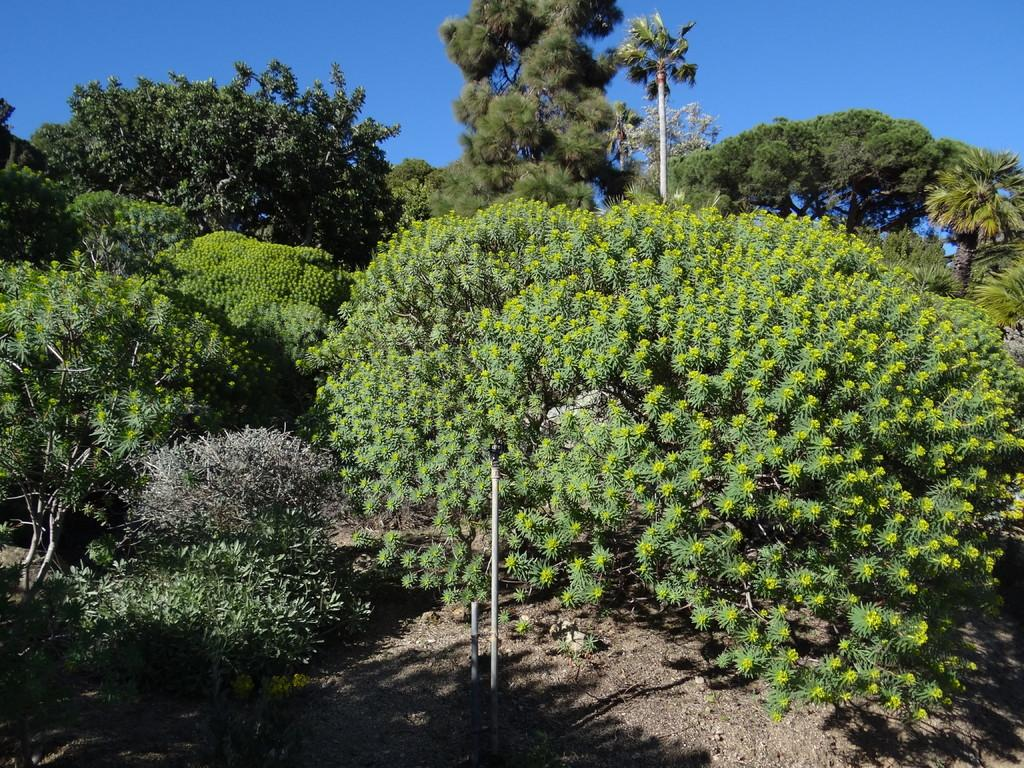What can be seen in the background of the image? There are trees and poles in the background of the image. What else is visible in the background of the image? The sky is visible in the background of the image. What type of honey is being collected by the creature in the image? There is no creature or honey present in the image. How many bags of popcorn are visible in the image? There are no bags of popcorn present in the image. 